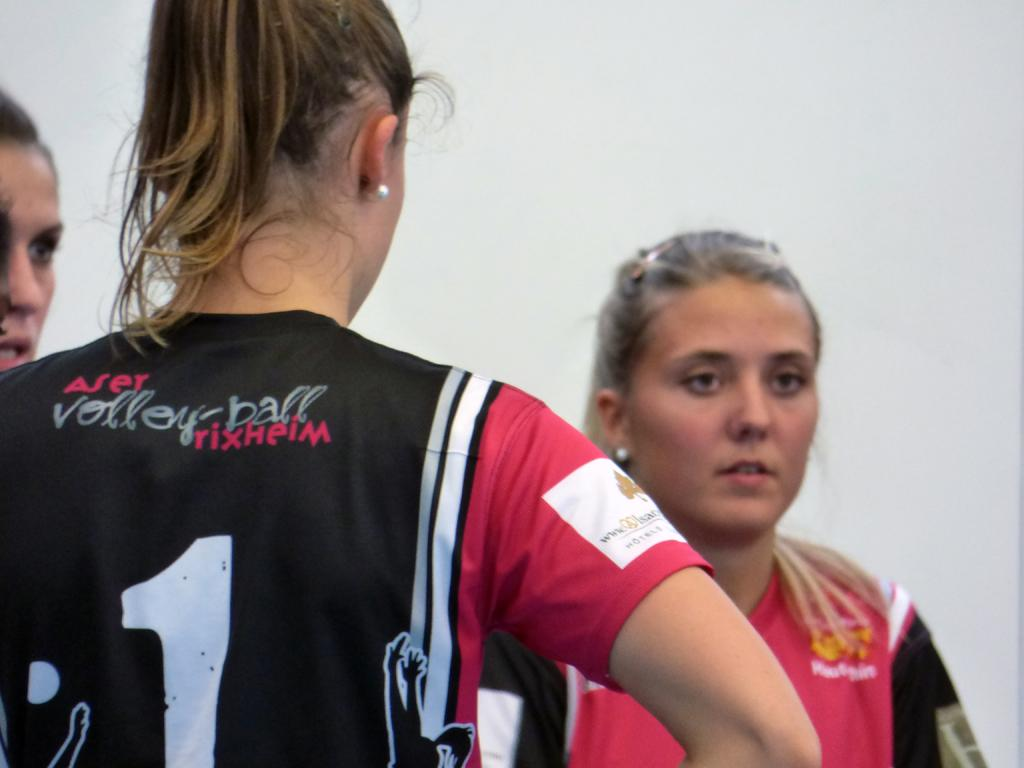<image>
Create a compact narrative representing the image presented. a volleyball player with a jersey that says ' aser volleyball rixheim' 